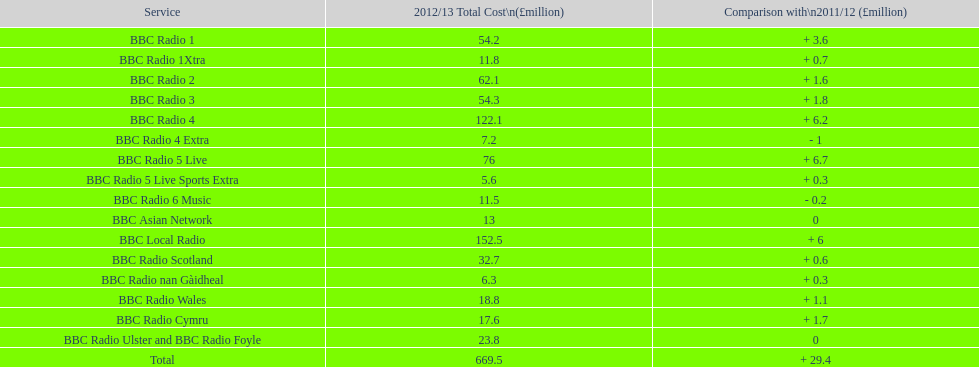What is the most amount of money spent to run a station in 2012/13? 152.5. What station costed 152.5 million pounds to run in this time? BBC Local Radio. 